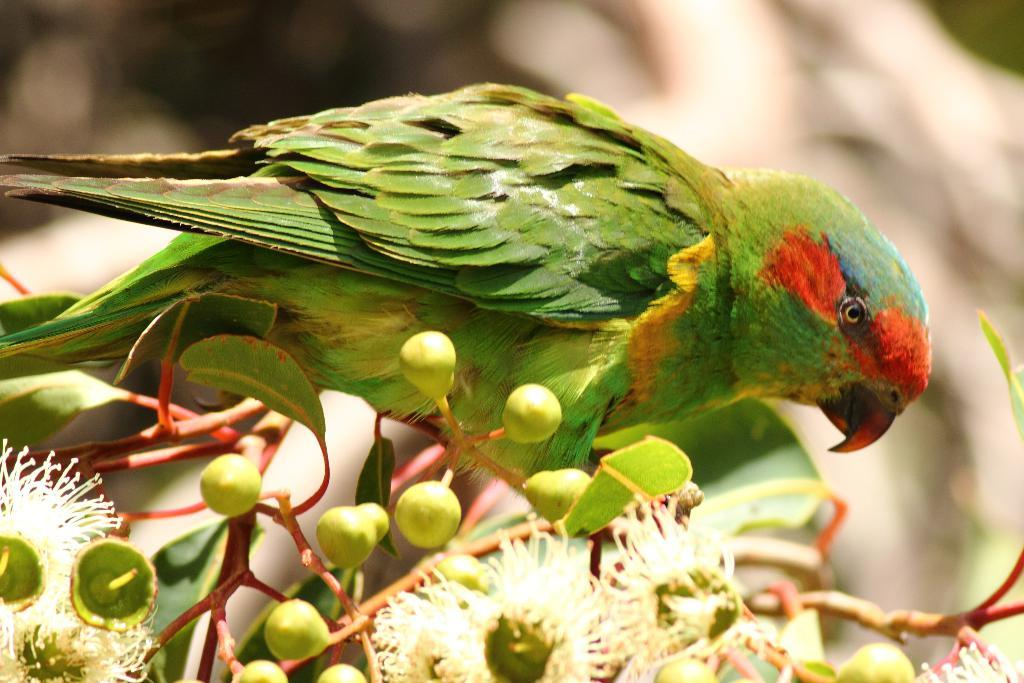What type of animal is in the image? There is a parrot in the image. Where is the parrot located? The parrot is on a plant. What can be observed about the plant? The plant has buds. How would you describe the background of the image? The background of the image is blurry. What type of vest is the parrot wearing in the image? The parrot is not wearing a vest in the image. Can you see any zippers on the plant in the image? There are no zippers present in the image; it features a parrot on a plant with buds. 